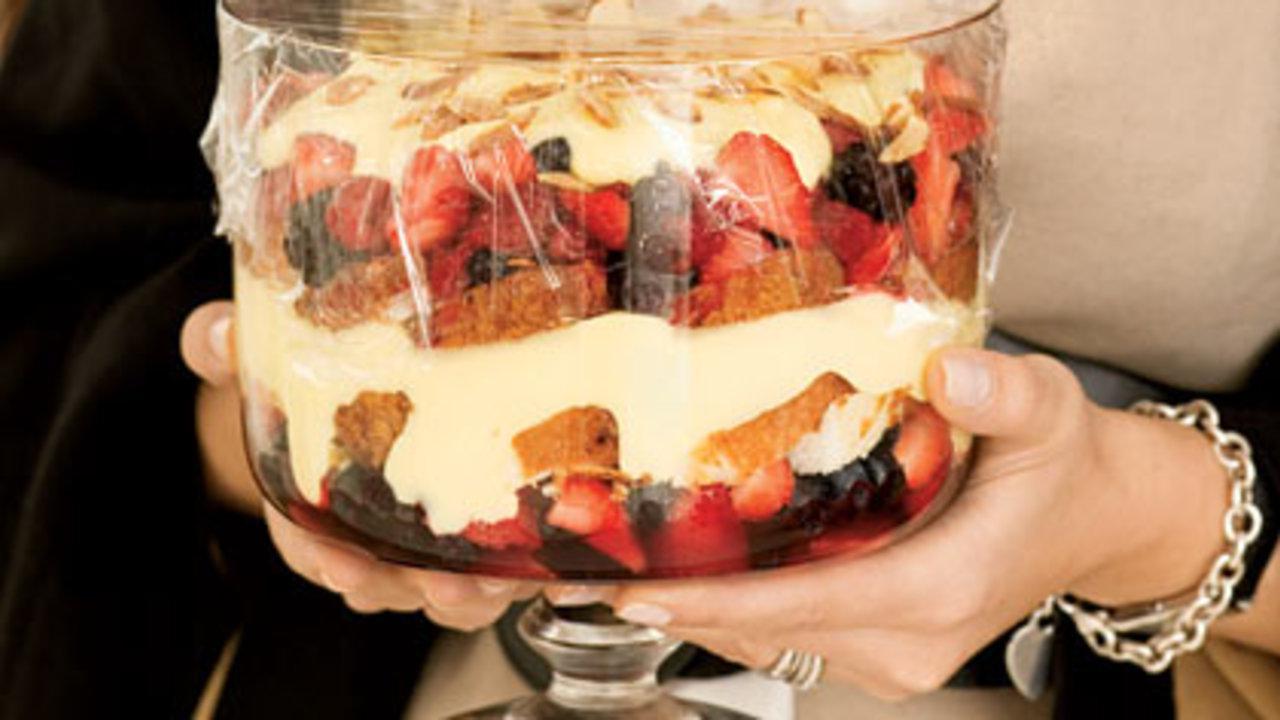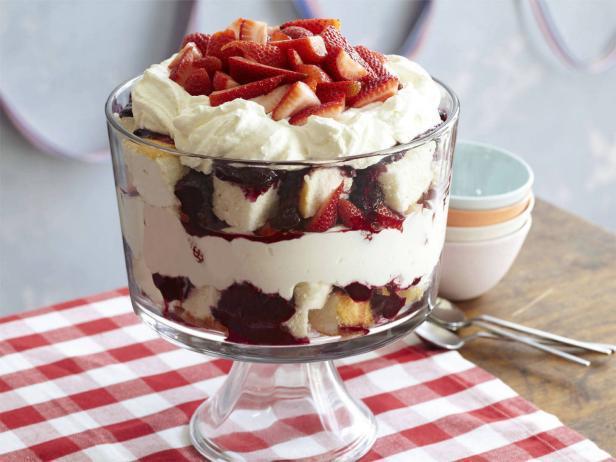The first image is the image on the left, the second image is the image on the right. For the images displayed, is the sentence "An image shows single-serve desserts garnished with blueberries and red raspberries." factually correct? Answer yes or no. No. The first image is the image on the left, the second image is the image on the right. Considering the images on both sides, is "Each image is a display of at least three individual trifle desserts that are topped with pieces of whole fruit." valid? Answer yes or no. No. 